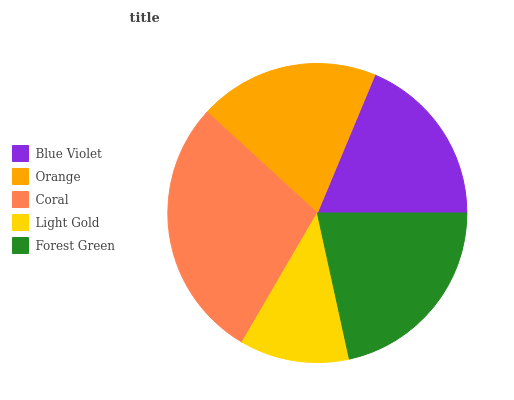Is Light Gold the minimum?
Answer yes or no. Yes. Is Coral the maximum?
Answer yes or no. Yes. Is Orange the minimum?
Answer yes or no. No. Is Orange the maximum?
Answer yes or no. No. Is Orange greater than Blue Violet?
Answer yes or no. Yes. Is Blue Violet less than Orange?
Answer yes or no. Yes. Is Blue Violet greater than Orange?
Answer yes or no. No. Is Orange less than Blue Violet?
Answer yes or no. No. Is Orange the high median?
Answer yes or no. Yes. Is Orange the low median?
Answer yes or no. Yes. Is Blue Violet the high median?
Answer yes or no. No. Is Forest Green the low median?
Answer yes or no. No. 